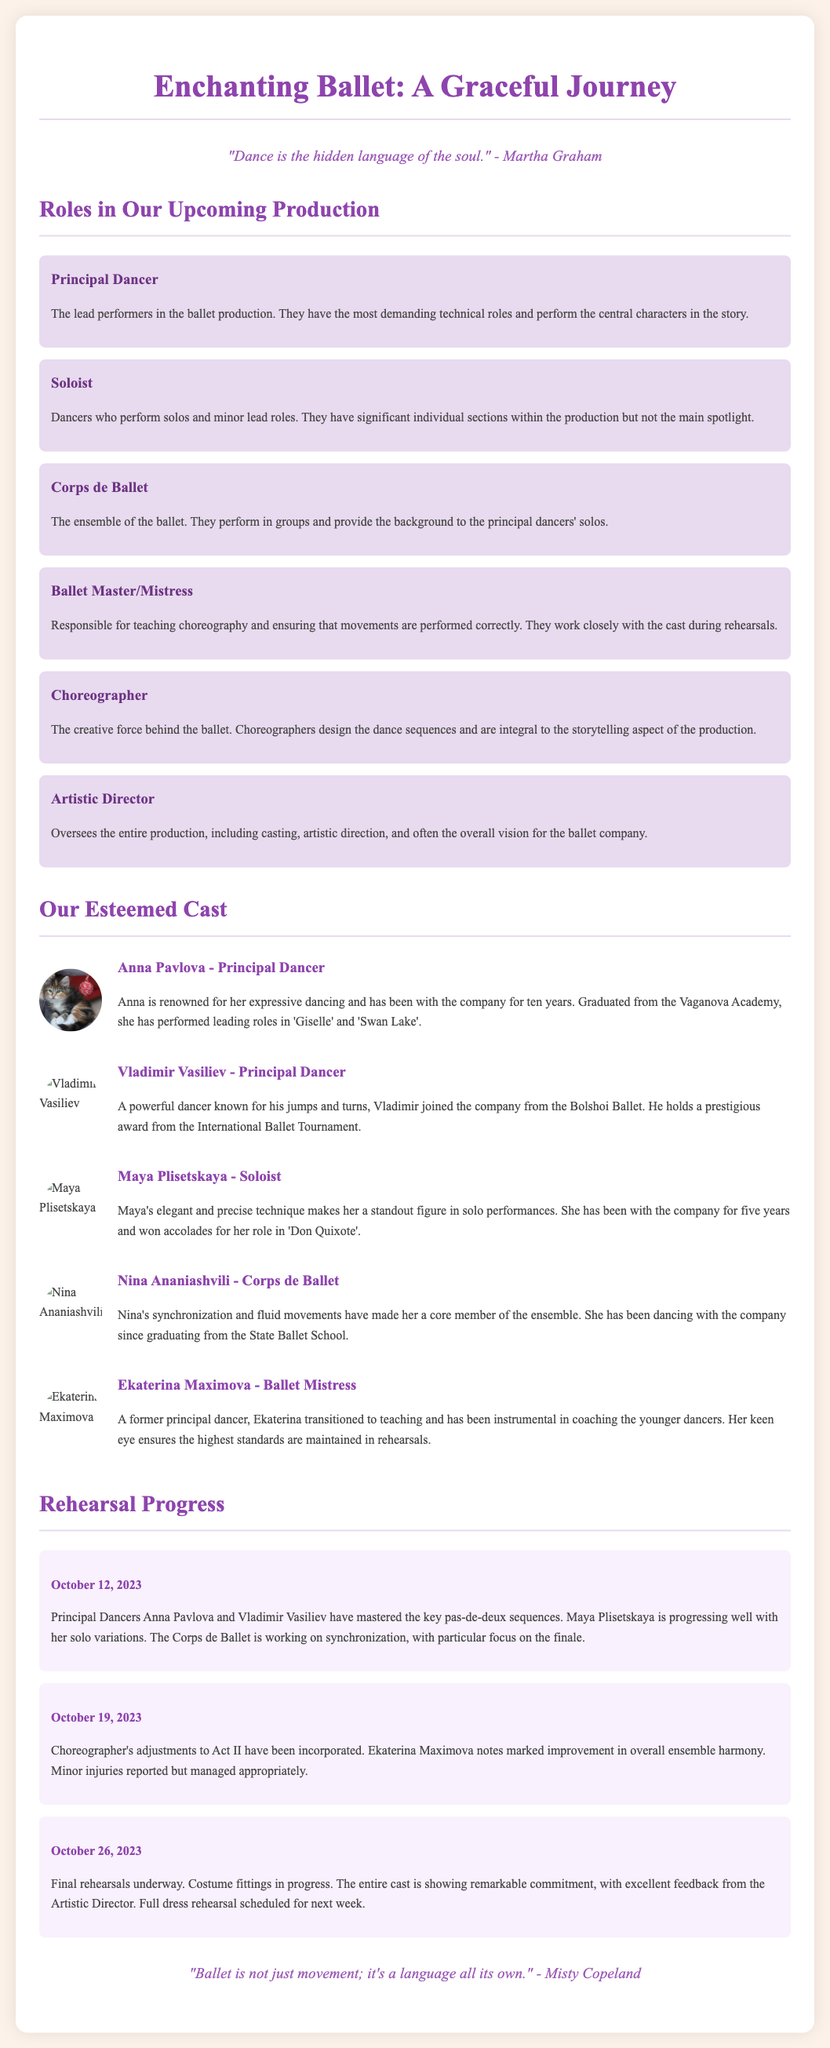What is the title of the ballet production? The title of the ballet production is found in the header of the document.
Answer: Enchanting Ballet: A Graceful Journey Who is the Artistic Director? The Artistic Director's role is mentioned under the roles in the production, but their name is not specified.
Answer: Not specified What is the primary responsibility of the Choreographer? The role of the Choreographer is detailed in the roles section focusing on design.
Answer: Design the dance sequences Which cast member is a Ballet Mistress? The document provides a list of cast members, identifying specific roles, including the Ballet Mistress.
Answer: Ekaterina Maximova What date was the rehearsal progress report on the final rehearsals? The final rehearsal progress date can be found within the Rehearsal Progress section of the document.
Answer: October 26, 2023 How long has Anna Pavlova been with the company? Anna Pavlova's experience with the ballet company is detailed in her biography section.
Answer: Ten years What is mentioned about the Corps de Ballet in the October 12 report? The October 12 report references the Corps de Ballet's rehearsal focus which can be found in that specific report detail.
Answer: Synchronization, focus on the finale Which two principal dancers mastered key pas-de-deux sequences? The names of the principal dancers are listed in the rehearsal progress report from October 12.
Answer: Anna Pavlova and Vladimir Vasiliev 